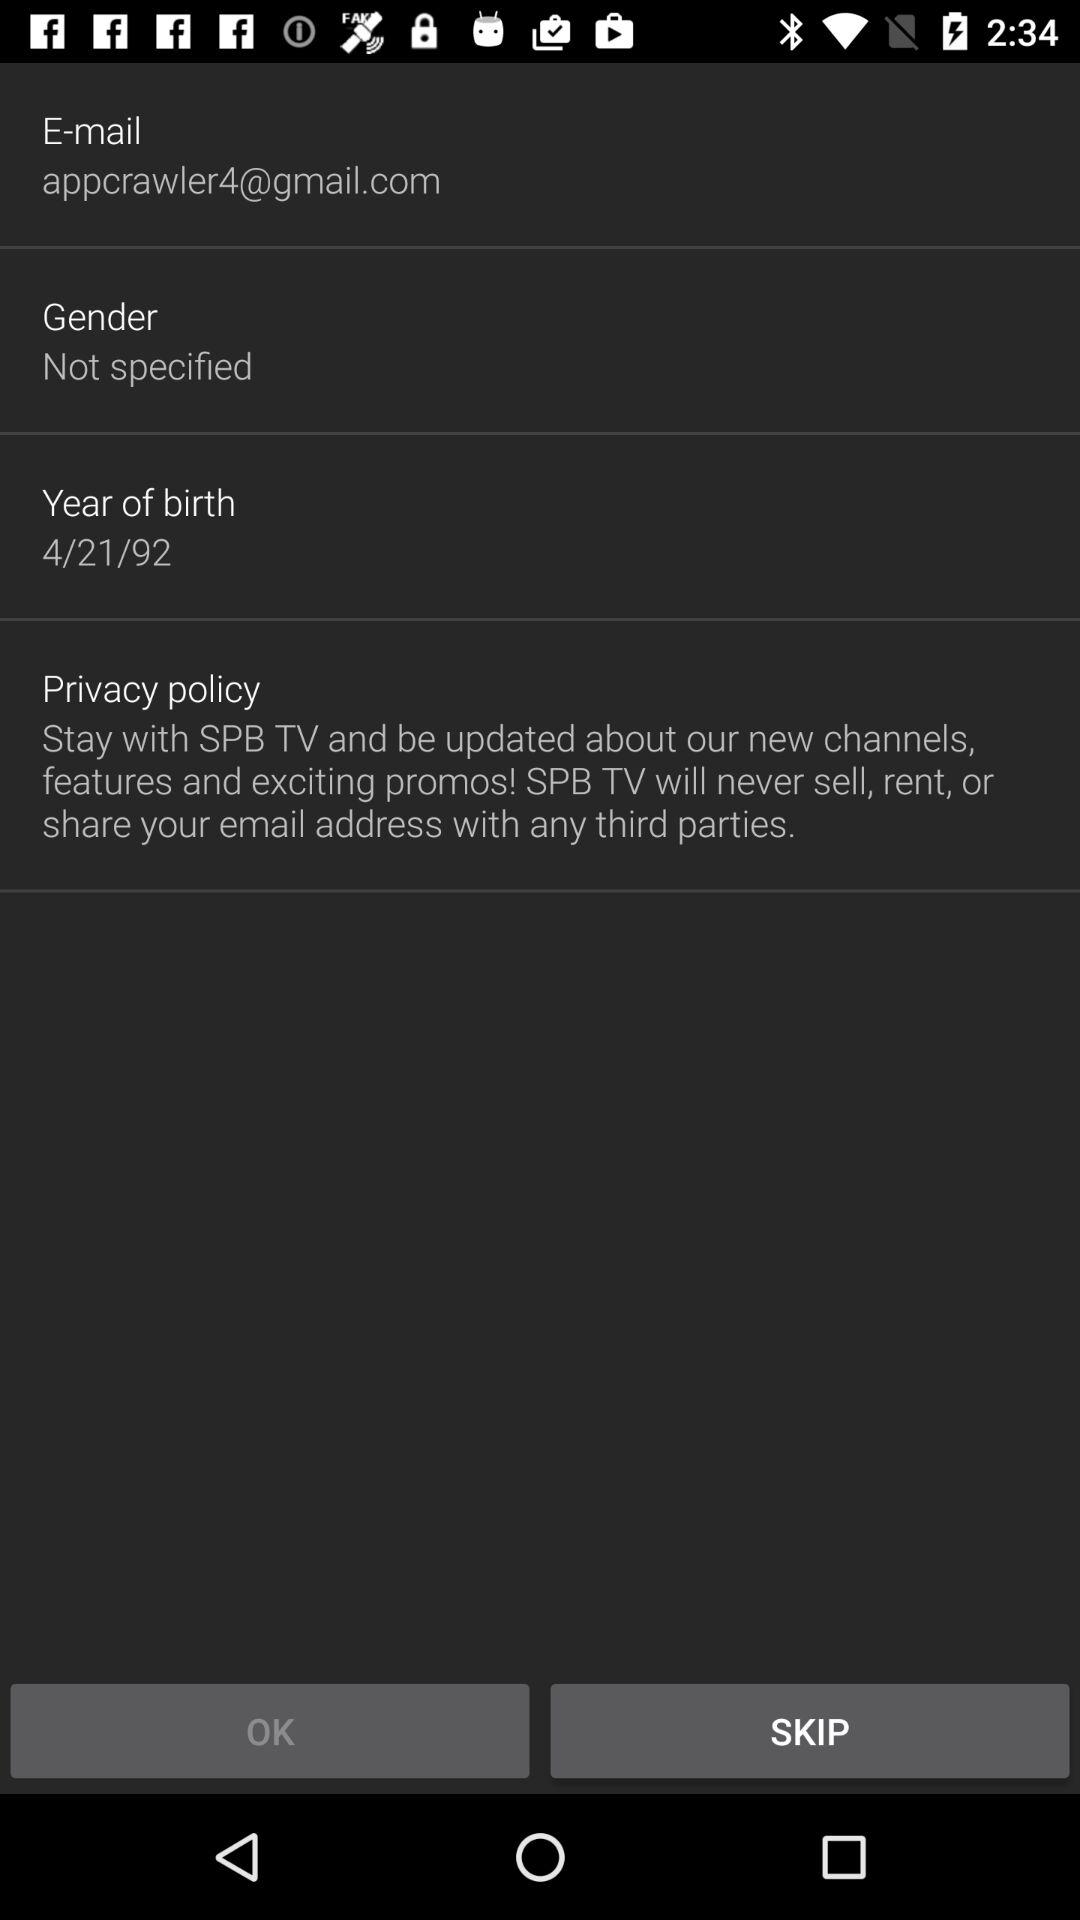What is the gender? The gender is not specified. 